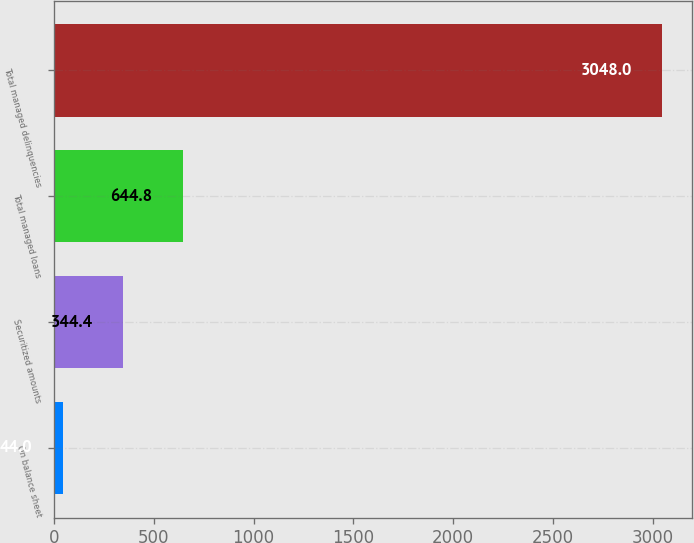<chart> <loc_0><loc_0><loc_500><loc_500><bar_chart><fcel>On balance sheet<fcel>Securitized amounts<fcel>Total managed loans<fcel>Total managed delinquencies<nl><fcel>44<fcel>344.4<fcel>644.8<fcel>3048<nl></chart> 